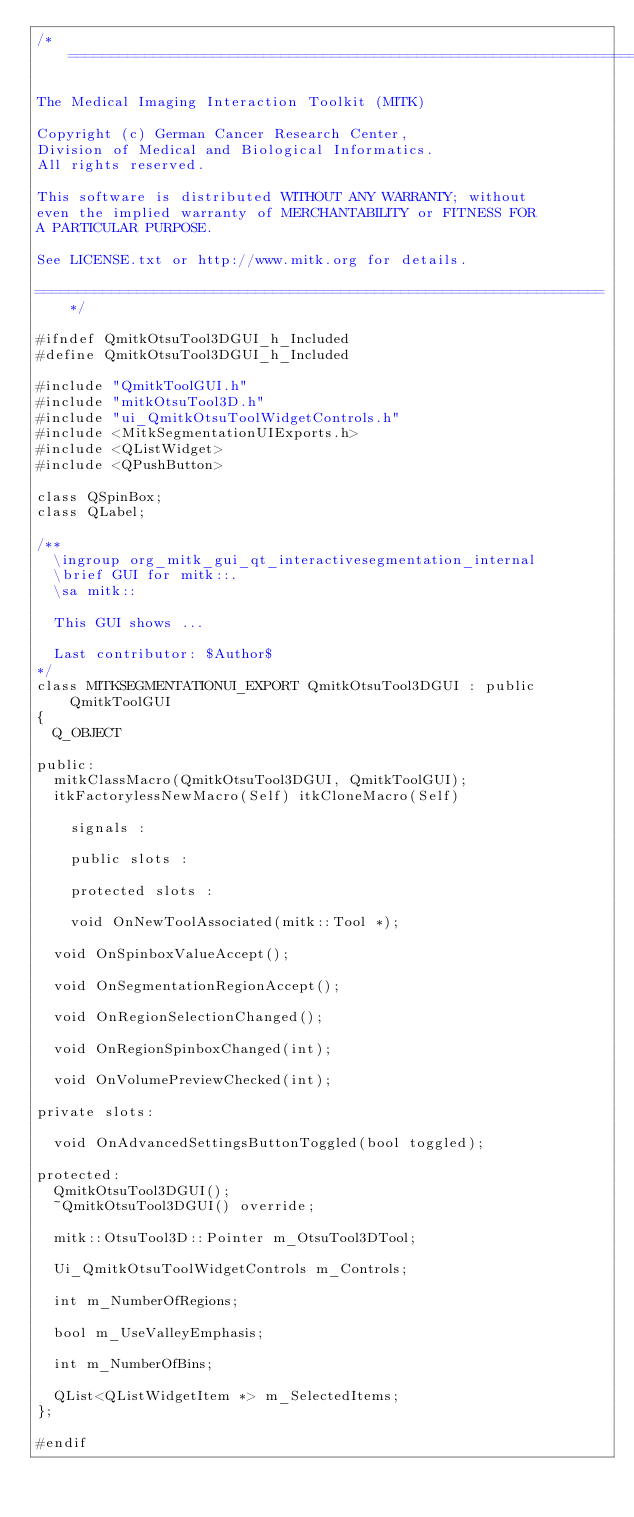<code> <loc_0><loc_0><loc_500><loc_500><_C_>/*===================================================================

The Medical Imaging Interaction Toolkit (MITK)

Copyright (c) German Cancer Research Center,
Division of Medical and Biological Informatics.
All rights reserved.

This software is distributed WITHOUT ANY WARRANTY; without
even the implied warranty of MERCHANTABILITY or FITNESS FOR
A PARTICULAR PURPOSE.

See LICENSE.txt or http://www.mitk.org for details.

===================================================================*/

#ifndef QmitkOtsuTool3DGUI_h_Included
#define QmitkOtsuTool3DGUI_h_Included

#include "QmitkToolGUI.h"
#include "mitkOtsuTool3D.h"
#include "ui_QmitkOtsuToolWidgetControls.h"
#include <MitkSegmentationUIExports.h>
#include <QListWidget>
#include <QPushButton>

class QSpinBox;
class QLabel;

/**
  \ingroup org_mitk_gui_qt_interactivesegmentation_internal
  \brief GUI for mitk::.
  \sa mitk::

  This GUI shows ...

  Last contributor: $Author$
*/
class MITKSEGMENTATIONUI_EXPORT QmitkOtsuTool3DGUI : public QmitkToolGUI
{
  Q_OBJECT

public:
  mitkClassMacro(QmitkOtsuTool3DGUI, QmitkToolGUI);
  itkFactorylessNewMacro(Self) itkCloneMacro(Self)

    signals :

    public slots :

    protected slots :

    void OnNewToolAssociated(mitk::Tool *);

  void OnSpinboxValueAccept();

  void OnSegmentationRegionAccept();

  void OnRegionSelectionChanged();

  void OnRegionSpinboxChanged(int);

  void OnVolumePreviewChecked(int);

private slots:

  void OnAdvancedSettingsButtonToggled(bool toggled);

protected:
  QmitkOtsuTool3DGUI();
  ~QmitkOtsuTool3DGUI() override;

  mitk::OtsuTool3D::Pointer m_OtsuTool3DTool;

  Ui_QmitkOtsuToolWidgetControls m_Controls;

  int m_NumberOfRegions;

  bool m_UseValleyEmphasis;

  int m_NumberOfBins;

  QList<QListWidgetItem *> m_SelectedItems;
};

#endif
</code> 